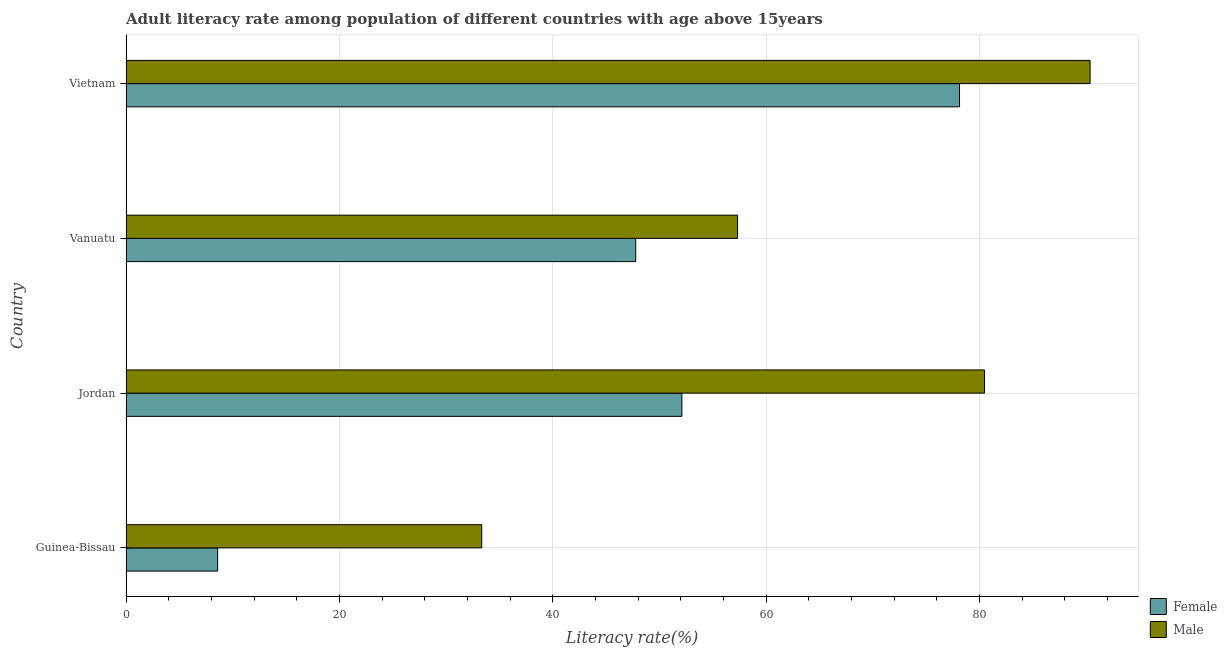How many different coloured bars are there?
Make the answer very short. 2. Are the number of bars per tick equal to the number of legend labels?
Ensure brevity in your answer.  Yes. What is the label of the 1st group of bars from the top?
Offer a terse response. Vietnam. In how many cases, is the number of bars for a given country not equal to the number of legend labels?
Give a very brief answer. 0. What is the male adult literacy rate in Guinea-Bissau?
Give a very brief answer. 33.35. Across all countries, what is the maximum female adult literacy rate?
Your answer should be compact. 78.14. Across all countries, what is the minimum female adult literacy rate?
Your answer should be very brief. 8.59. In which country was the female adult literacy rate maximum?
Keep it short and to the point. Vietnam. In which country was the male adult literacy rate minimum?
Ensure brevity in your answer.  Guinea-Bissau. What is the total male adult literacy rate in the graph?
Your answer should be compact. 261.55. What is the difference between the female adult literacy rate in Guinea-Bissau and that in Vanuatu?
Your response must be concise. -39.19. What is the difference between the female adult literacy rate in Vietnam and the male adult literacy rate in Guinea-Bissau?
Make the answer very short. 44.79. What is the average female adult literacy rate per country?
Provide a succinct answer. 46.66. What is the difference between the male adult literacy rate and female adult literacy rate in Vietnam?
Keep it short and to the point. 12.24. In how many countries, is the female adult literacy rate greater than 24 %?
Offer a very short reply. 3. What is the ratio of the female adult literacy rate in Vanuatu to that in Vietnam?
Provide a short and direct response. 0.61. Is the male adult literacy rate in Jordan less than that in Vietnam?
Ensure brevity in your answer.  Yes. Is the difference between the female adult literacy rate in Guinea-Bissau and Vietnam greater than the difference between the male adult literacy rate in Guinea-Bissau and Vietnam?
Offer a very short reply. No. What is the difference between the highest and the second highest female adult literacy rate?
Make the answer very short. 26.03. What is the difference between the highest and the lowest female adult literacy rate?
Your answer should be compact. 69.55. In how many countries, is the female adult literacy rate greater than the average female adult literacy rate taken over all countries?
Ensure brevity in your answer.  3. What does the 2nd bar from the top in Vanuatu represents?
Your response must be concise. Female. How many bars are there?
Your answer should be compact. 8. What is the difference between two consecutive major ticks on the X-axis?
Make the answer very short. 20. What is the title of the graph?
Provide a short and direct response. Adult literacy rate among population of different countries with age above 15years. Does "Highest 20% of population" appear as one of the legend labels in the graph?
Give a very brief answer. No. What is the label or title of the X-axis?
Keep it short and to the point. Literacy rate(%). What is the Literacy rate(%) of Female in Guinea-Bissau?
Your answer should be compact. 8.59. What is the Literacy rate(%) of Male in Guinea-Bissau?
Your answer should be compact. 33.35. What is the Literacy rate(%) in Female in Jordan?
Offer a terse response. 52.11. What is the Literacy rate(%) in Male in Jordan?
Give a very brief answer. 80.48. What is the Literacy rate(%) in Female in Vanuatu?
Your response must be concise. 47.78. What is the Literacy rate(%) of Male in Vanuatu?
Keep it short and to the point. 57.34. What is the Literacy rate(%) of Female in Vietnam?
Your answer should be compact. 78.14. What is the Literacy rate(%) in Male in Vietnam?
Offer a very short reply. 90.38. Across all countries, what is the maximum Literacy rate(%) of Female?
Provide a succinct answer. 78.14. Across all countries, what is the maximum Literacy rate(%) of Male?
Give a very brief answer. 90.38. Across all countries, what is the minimum Literacy rate(%) of Female?
Your answer should be very brief. 8.59. Across all countries, what is the minimum Literacy rate(%) of Male?
Your answer should be compact. 33.35. What is the total Literacy rate(%) in Female in the graph?
Make the answer very short. 186.62. What is the total Literacy rate(%) in Male in the graph?
Your answer should be very brief. 261.55. What is the difference between the Literacy rate(%) in Female in Guinea-Bissau and that in Jordan?
Offer a terse response. -43.52. What is the difference between the Literacy rate(%) in Male in Guinea-Bissau and that in Jordan?
Your response must be concise. -47.13. What is the difference between the Literacy rate(%) of Female in Guinea-Bissau and that in Vanuatu?
Your response must be concise. -39.19. What is the difference between the Literacy rate(%) in Male in Guinea-Bissau and that in Vanuatu?
Provide a succinct answer. -23.99. What is the difference between the Literacy rate(%) of Female in Guinea-Bissau and that in Vietnam?
Provide a succinct answer. -69.55. What is the difference between the Literacy rate(%) of Male in Guinea-Bissau and that in Vietnam?
Keep it short and to the point. -57.03. What is the difference between the Literacy rate(%) in Female in Jordan and that in Vanuatu?
Offer a terse response. 4.33. What is the difference between the Literacy rate(%) in Male in Jordan and that in Vanuatu?
Provide a succinct answer. 23.15. What is the difference between the Literacy rate(%) of Female in Jordan and that in Vietnam?
Your answer should be very brief. -26.03. What is the difference between the Literacy rate(%) of Male in Jordan and that in Vietnam?
Your answer should be very brief. -9.9. What is the difference between the Literacy rate(%) of Female in Vanuatu and that in Vietnam?
Your answer should be very brief. -30.36. What is the difference between the Literacy rate(%) of Male in Vanuatu and that in Vietnam?
Keep it short and to the point. -33.05. What is the difference between the Literacy rate(%) of Female in Guinea-Bissau and the Literacy rate(%) of Male in Jordan?
Keep it short and to the point. -71.89. What is the difference between the Literacy rate(%) in Female in Guinea-Bissau and the Literacy rate(%) in Male in Vanuatu?
Offer a very short reply. -48.75. What is the difference between the Literacy rate(%) in Female in Guinea-Bissau and the Literacy rate(%) in Male in Vietnam?
Offer a very short reply. -81.79. What is the difference between the Literacy rate(%) of Female in Jordan and the Literacy rate(%) of Male in Vanuatu?
Keep it short and to the point. -5.22. What is the difference between the Literacy rate(%) of Female in Jordan and the Literacy rate(%) of Male in Vietnam?
Provide a short and direct response. -38.27. What is the difference between the Literacy rate(%) of Female in Vanuatu and the Literacy rate(%) of Male in Vietnam?
Provide a short and direct response. -42.6. What is the average Literacy rate(%) of Female per country?
Your answer should be very brief. 46.66. What is the average Literacy rate(%) in Male per country?
Provide a short and direct response. 65.39. What is the difference between the Literacy rate(%) of Female and Literacy rate(%) of Male in Guinea-Bissau?
Provide a succinct answer. -24.76. What is the difference between the Literacy rate(%) of Female and Literacy rate(%) of Male in Jordan?
Offer a very short reply. -28.37. What is the difference between the Literacy rate(%) in Female and Literacy rate(%) in Male in Vanuatu?
Offer a very short reply. -9.55. What is the difference between the Literacy rate(%) of Female and Literacy rate(%) of Male in Vietnam?
Make the answer very short. -12.24. What is the ratio of the Literacy rate(%) of Female in Guinea-Bissau to that in Jordan?
Your response must be concise. 0.16. What is the ratio of the Literacy rate(%) in Male in Guinea-Bissau to that in Jordan?
Offer a very short reply. 0.41. What is the ratio of the Literacy rate(%) in Female in Guinea-Bissau to that in Vanuatu?
Provide a short and direct response. 0.18. What is the ratio of the Literacy rate(%) in Male in Guinea-Bissau to that in Vanuatu?
Offer a very short reply. 0.58. What is the ratio of the Literacy rate(%) of Female in Guinea-Bissau to that in Vietnam?
Your response must be concise. 0.11. What is the ratio of the Literacy rate(%) of Male in Guinea-Bissau to that in Vietnam?
Offer a very short reply. 0.37. What is the ratio of the Literacy rate(%) in Female in Jordan to that in Vanuatu?
Offer a very short reply. 1.09. What is the ratio of the Literacy rate(%) of Male in Jordan to that in Vanuatu?
Offer a very short reply. 1.4. What is the ratio of the Literacy rate(%) of Female in Jordan to that in Vietnam?
Offer a very short reply. 0.67. What is the ratio of the Literacy rate(%) of Male in Jordan to that in Vietnam?
Offer a terse response. 0.89. What is the ratio of the Literacy rate(%) in Female in Vanuatu to that in Vietnam?
Make the answer very short. 0.61. What is the ratio of the Literacy rate(%) of Male in Vanuatu to that in Vietnam?
Your answer should be compact. 0.63. What is the difference between the highest and the second highest Literacy rate(%) of Female?
Give a very brief answer. 26.03. What is the difference between the highest and the second highest Literacy rate(%) of Male?
Your answer should be very brief. 9.9. What is the difference between the highest and the lowest Literacy rate(%) of Female?
Give a very brief answer. 69.55. What is the difference between the highest and the lowest Literacy rate(%) in Male?
Offer a terse response. 57.03. 